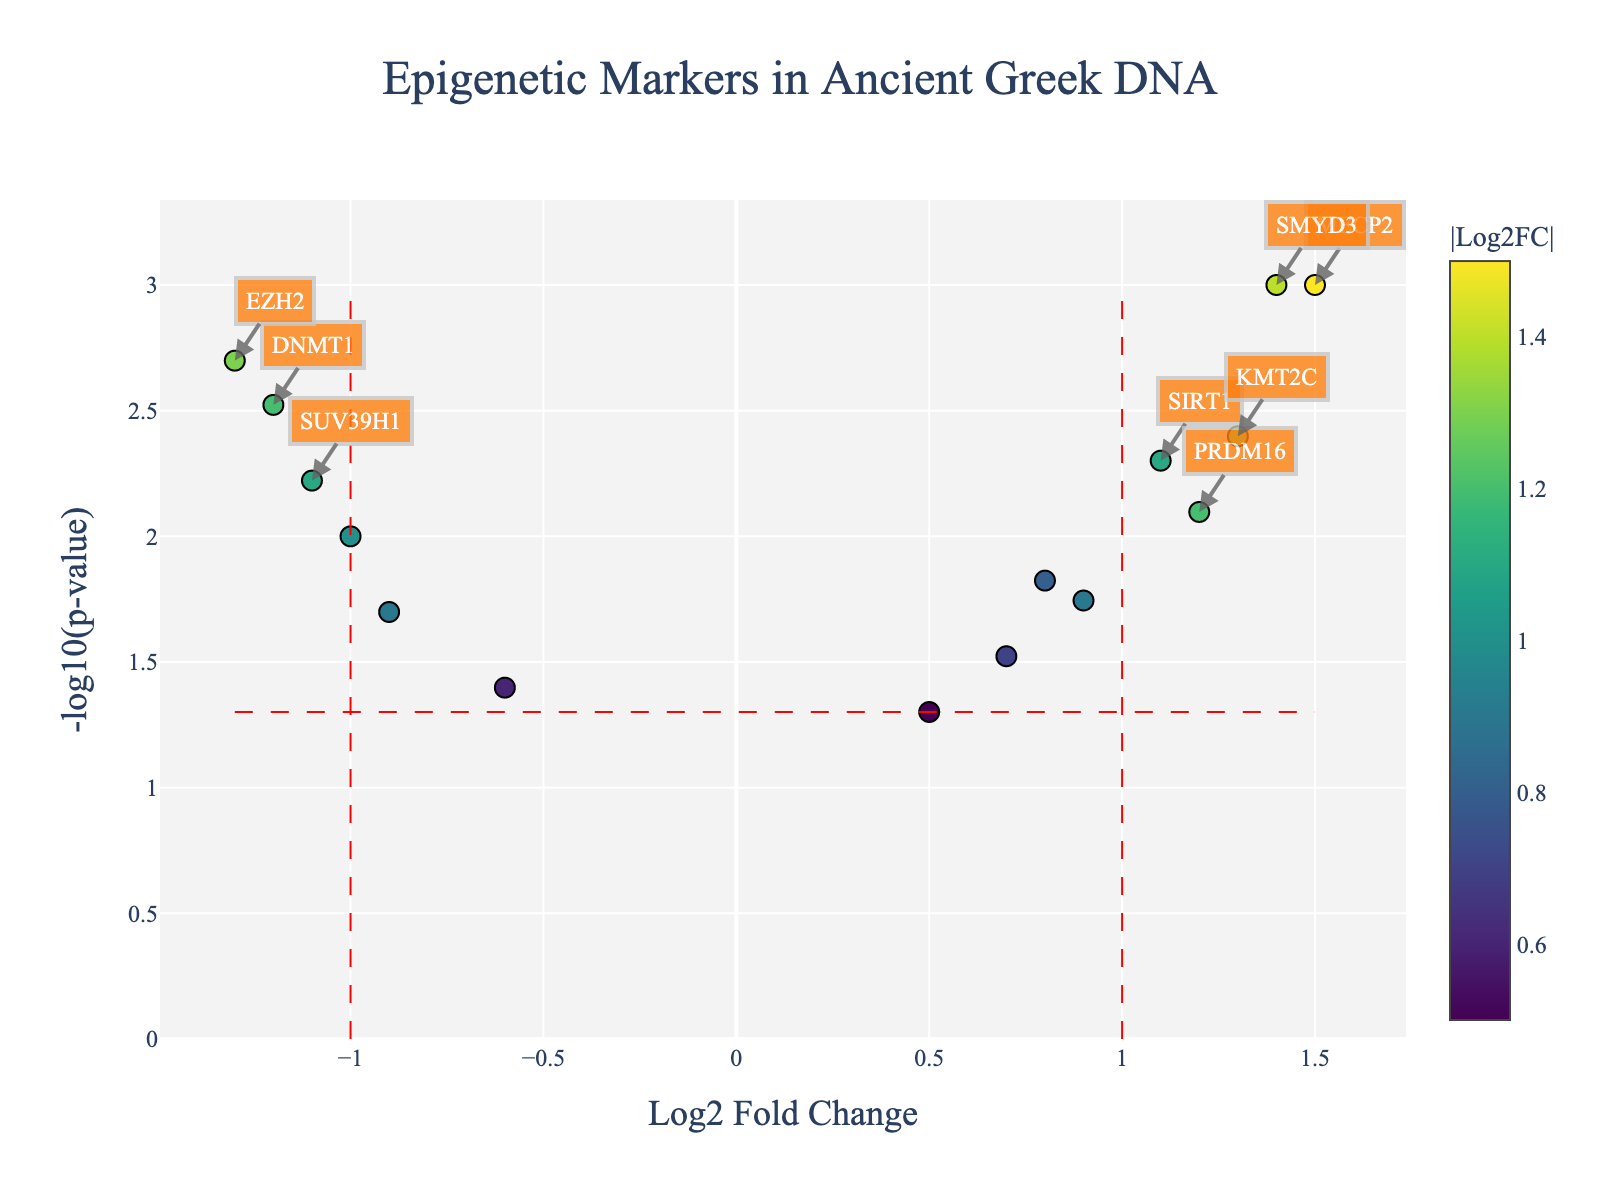How many genes have a Log2 Fold Change greater than 1? To find the number of genes with a Log2 Fold Change greater than 1, look at the data points on the x-axis that are to the right of the vertical red dashed line at x=1. Count these points.
Answer: Four genes Which gene has the smallest p-value? The smallest p-value will correspond to the highest point on the y-axis since -log10(p-value) translates to higher y-values. Identify the highest data point on the plot.
Answer: MECP2 Which gene shows the most significant down-regulation? For the most significant down-regulation, look for the gene with the most negative Log2 Fold Change while also having a low p-value (high on the y-axis).
Answer: EZH2 What is the Log2 Fold Change and p-value of the gene PRDM16? Refer to the hover information for the data point corresponding to PRDM16. The hover will show Log2 Fold Change and p-value.
Answer: Log2 Fold Change: 1.2, p-value: 0.008 Compare the significance of SIRT1 and SETD7. Which gene has a more significant result? Significance is measured by the p-value. Compare the y-values (-log10(p-value)) of SIRT1 and SETD7. The one with a higher y-value is more significant.
Answer: SIRT1 Identify the range of -log10(p-value) for the data points. Find the minimum and maximum y-values on the plot, which represent -log10(p-value).
Answer: Range: 1.301 to 3.000 What is the overall trend of up-regulated versus down-regulated genes? Count the data points on the left side of x=0 (down-regulated) and on the right side of x=0 (up-regulated).
Answer: Similar counts with slight more up-regulated 